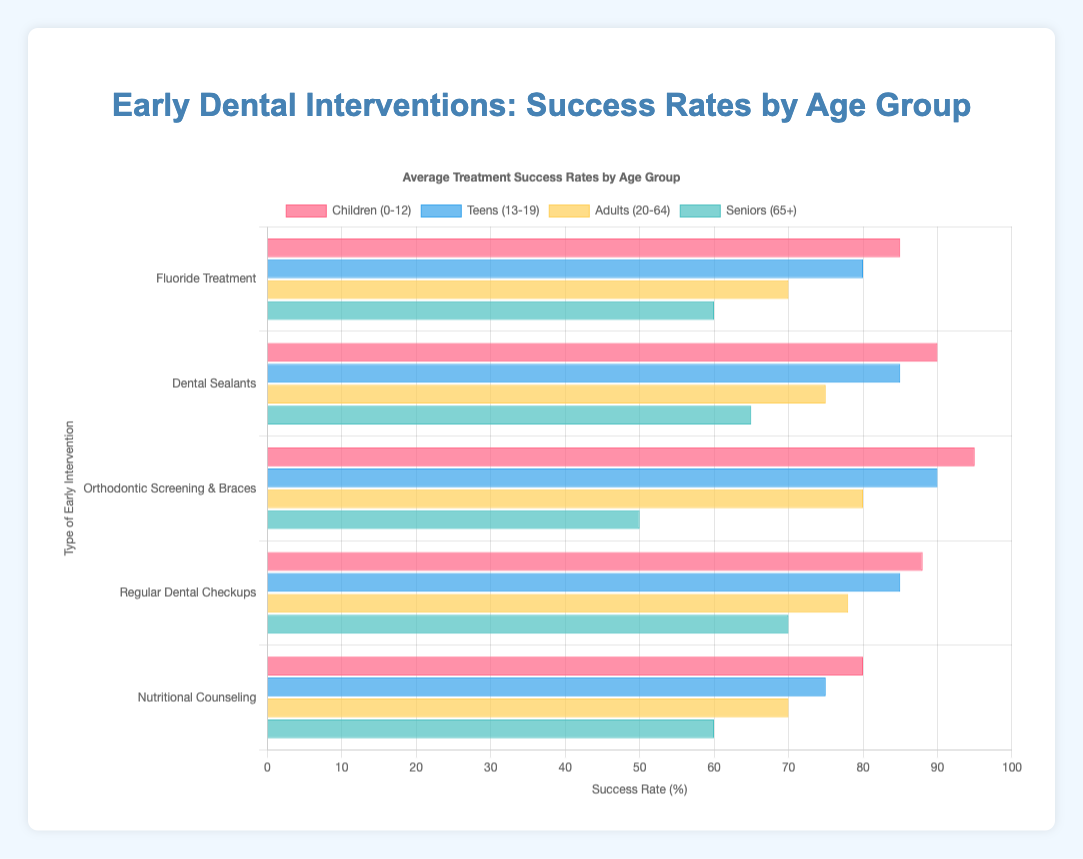Which intervention has the highest success rate for children (0-12)? The bar representing "Orthodontic Screening & Braces" for children (0-12) is the tallest, indicating the highest success rate among all interventions.
Answer: Orthodontic Screening & Braces What is the difference in success rates between Fluoride Treatment and Dental Sealants for teens (13-19)? The success rate for Fluoride Treatment for teens (13-19) is 80%, while for Dental Sealants it is 85%. Subtracting these values gives us the difference: 85% - 80% = 5%.
Answer: 5% Which age group has the lowest success rate for Orthodontic Screening & Braces? By comparing the heights of the bars for Orthodontic Screening & Braces, the bar for seniors (65+) is the shortest, indicating the lowest success rate.
Answer: Seniors (65+) Among all interventions, which one has the least variability in success rates across different age groups? The heights of the bars for Regular Dental Checkups are closest to each other across all age groups, implying the least variability in success rates.
Answer: Regular Dental Checkups Which intervention shows a decline in success rate with increasing age? Observing the trends in the bar heights, Fluoride Treatment, Dental Sealants, and Nutritional Counseling all show a clear decline in success rates as age increases from children to seniors.
Answer: Fluoride Treatment, Dental Sealants, Nutritional Counseling What is the average success rate for Regular Dental Checkups across all age groups? The success rates for Regular Dental Checkups are 88%, 85%, 78%, and 70%. Calculating the average involves summing these values and dividing by 4: (88 + 85 + 78 + 70)/4 = 80.25%.
Answer: 80.25% How does the success rate of Nutritional Counseling for seniors (65+) compare to that for children (0-12)? The success rate for Nutritional Counseling for seniors (65+) is 60%, while it is 80% for children (0-12). So, the rate for children is higher by 80% - 60% = 20%.
Answer: Children (0-12) have a 20% higher success rate than seniors (65+) For which age group is the difference between the highest and lowest success rates the greatest? By comparing the range (difference between highest and lowest rates) for each age group, seniors (65+) have the widest range: Orthodontic Screening & Braces (50%), Nutritional Counseling (60%), Dental Sealants (65%), Fluoride Treatment (60%), and Regular Dental Checkups (70%). The range is 70% - 50% = 20%.
Answer: Seniors (65+) What is the total success rate of all interventions for adults (20-64)? Summing the success rates for adults for all interventions: 70% (Fluoride Treatment) + 75% (Dental Sealants) + 80% (Orthodontic Screening & Braces) + 78% (Regular Dental Checkups) + 70% (Nutritional Counseling) = 373%.
Answer: 373% What percentage of the interventions have a success rate of 85% or higher for teens (13-19)? The interventions with success rates of 85% or higher for teens are Fluoride Treatment (80%), Dental Sealants (85%), Orthodontic Screening & Braces (90%), Regular Dental Checkups (85%), and Nutritional Counseling (75%). Out of these, Dental Sealants, Orthodontic Screening & Braces, and Regular Dental Checkups meet the criteria. This makes 3 out of 5, which is (3/5)*100 = 60%.
Answer: 60% 